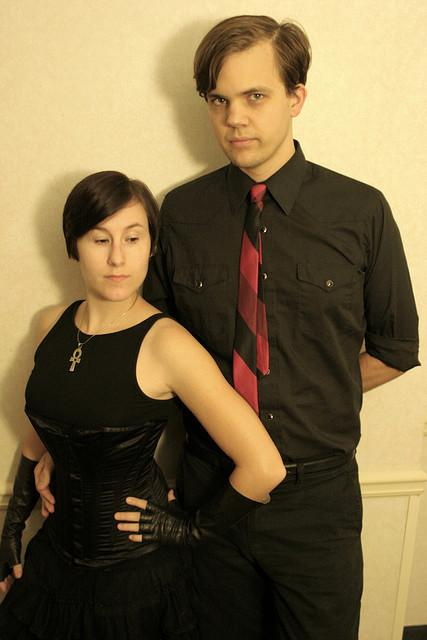What's the name of the pendant on the woman's necklace? Please explain your reasoning. ankh. A woman is wearing a necklace with a charm on it. 